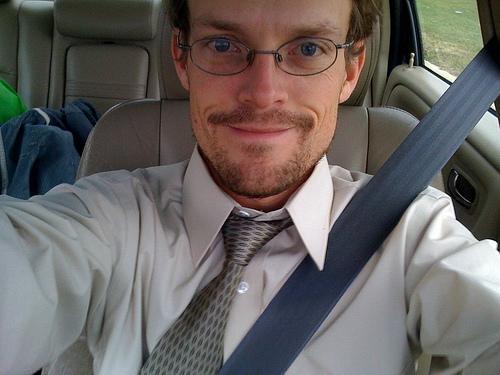How many horses do not have riders?
Give a very brief answer. 0. 